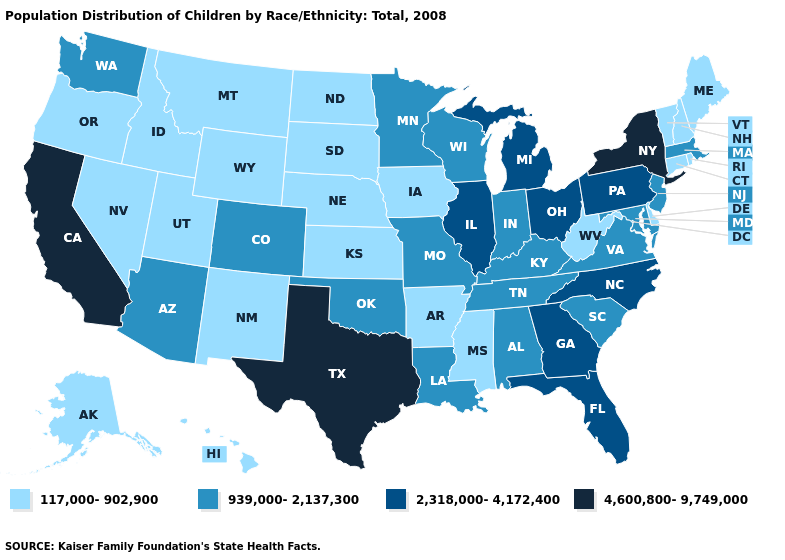What is the value of New Hampshire?
Quick response, please. 117,000-902,900. Does Alaska have the lowest value in the West?
Quick response, please. Yes. Does Florida have the same value as North Carolina?
Write a very short answer. Yes. What is the value of Delaware?
Answer briefly. 117,000-902,900. Name the states that have a value in the range 939,000-2,137,300?
Be succinct. Alabama, Arizona, Colorado, Indiana, Kentucky, Louisiana, Maryland, Massachusetts, Minnesota, Missouri, New Jersey, Oklahoma, South Carolina, Tennessee, Virginia, Washington, Wisconsin. What is the value of Maryland?
Answer briefly. 939,000-2,137,300. Name the states that have a value in the range 117,000-902,900?
Be succinct. Alaska, Arkansas, Connecticut, Delaware, Hawaii, Idaho, Iowa, Kansas, Maine, Mississippi, Montana, Nebraska, Nevada, New Hampshire, New Mexico, North Dakota, Oregon, Rhode Island, South Dakota, Utah, Vermont, West Virginia, Wyoming. What is the lowest value in the USA?
Concise answer only. 117,000-902,900. What is the value of South Dakota?
Quick response, please. 117,000-902,900. What is the highest value in states that border Vermont?
Give a very brief answer. 4,600,800-9,749,000. What is the value of Nevada?
Short answer required. 117,000-902,900. What is the value of Louisiana?
Short answer required. 939,000-2,137,300. Which states hav the highest value in the Northeast?
Quick response, please. New York. Does Montana have the lowest value in the USA?
Quick response, please. Yes. What is the value of Wisconsin?
Give a very brief answer. 939,000-2,137,300. 